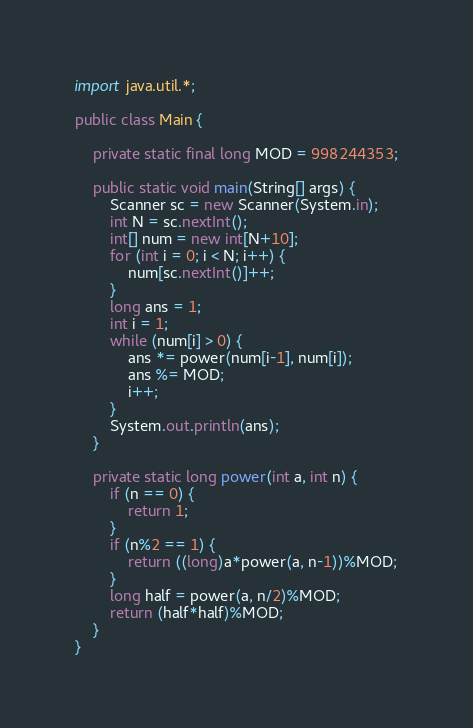Convert code to text. <code><loc_0><loc_0><loc_500><loc_500><_Java_>import java.util.*;
 
public class Main {

    private static final long MOD = 998244353;

    public static void main(String[] args) {
        Scanner sc = new Scanner(System.in);
        int N = sc.nextInt();
        int[] num = new int[N+10];
        for (int i = 0; i < N; i++) {
            num[sc.nextInt()]++;
        }
        long ans = 1;
        int i = 1;
        while (num[i] > 0) {
            ans *= power(num[i-1], num[i]);
            ans %= MOD;
            i++;
        }
        System.out.println(ans);
    }

    private static long power(int a, int n) {
        if (n == 0) {
            return 1;
        }
        if (n%2 == 1) {
            return ((long)a*power(a, n-1))%MOD;
        }
        long half = power(a, n/2)%MOD;
        return (half*half)%MOD;
    }
}
</code> 